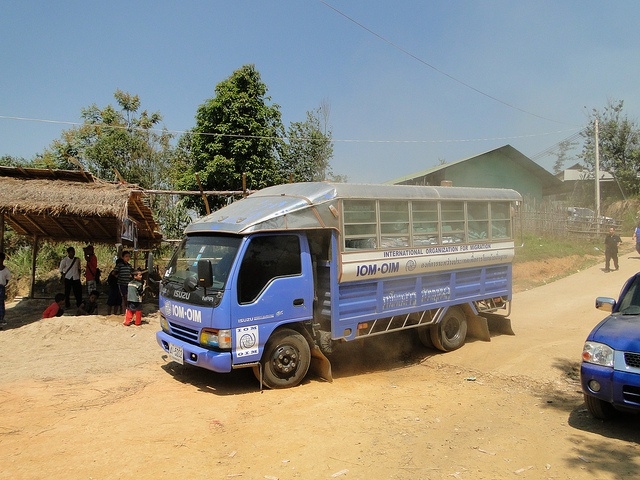Describe the objects in this image and their specific colors. I can see truck in gray, black, and darkgray tones, car in gray, black, and darkgray tones, people in gray, black, olive, and maroon tones, people in gray and black tones, and people in gray, black, maroon, and red tones in this image. 